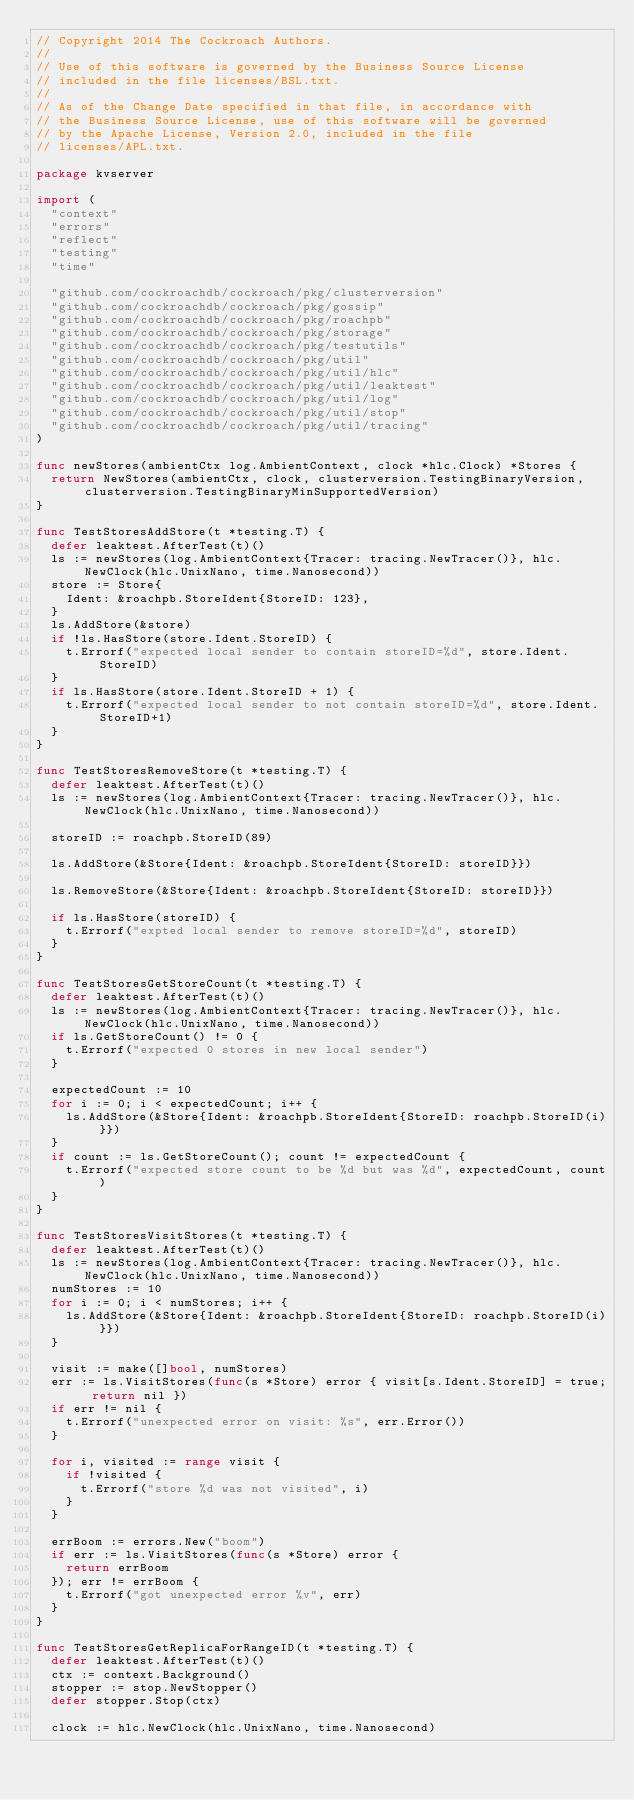Convert code to text. <code><loc_0><loc_0><loc_500><loc_500><_Go_>// Copyright 2014 The Cockroach Authors.
//
// Use of this software is governed by the Business Source License
// included in the file licenses/BSL.txt.
//
// As of the Change Date specified in that file, in accordance with
// the Business Source License, use of this software will be governed
// by the Apache License, Version 2.0, included in the file
// licenses/APL.txt.

package kvserver

import (
	"context"
	"errors"
	"reflect"
	"testing"
	"time"

	"github.com/cockroachdb/cockroach/pkg/clusterversion"
	"github.com/cockroachdb/cockroach/pkg/gossip"
	"github.com/cockroachdb/cockroach/pkg/roachpb"
	"github.com/cockroachdb/cockroach/pkg/storage"
	"github.com/cockroachdb/cockroach/pkg/testutils"
	"github.com/cockroachdb/cockroach/pkg/util"
	"github.com/cockroachdb/cockroach/pkg/util/hlc"
	"github.com/cockroachdb/cockroach/pkg/util/leaktest"
	"github.com/cockroachdb/cockroach/pkg/util/log"
	"github.com/cockroachdb/cockroach/pkg/util/stop"
	"github.com/cockroachdb/cockroach/pkg/util/tracing"
)

func newStores(ambientCtx log.AmbientContext, clock *hlc.Clock) *Stores {
	return NewStores(ambientCtx, clock, clusterversion.TestingBinaryVersion, clusterversion.TestingBinaryMinSupportedVersion)
}

func TestStoresAddStore(t *testing.T) {
	defer leaktest.AfterTest(t)()
	ls := newStores(log.AmbientContext{Tracer: tracing.NewTracer()}, hlc.NewClock(hlc.UnixNano, time.Nanosecond))
	store := Store{
		Ident: &roachpb.StoreIdent{StoreID: 123},
	}
	ls.AddStore(&store)
	if !ls.HasStore(store.Ident.StoreID) {
		t.Errorf("expected local sender to contain storeID=%d", store.Ident.StoreID)
	}
	if ls.HasStore(store.Ident.StoreID + 1) {
		t.Errorf("expected local sender to not contain storeID=%d", store.Ident.StoreID+1)
	}
}

func TestStoresRemoveStore(t *testing.T) {
	defer leaktest.AfterTest(t)()
	ls := newStores(log.AmbientContext{Tracer: tracing.NewTracer()}, hlc.NewClock(hlc.UnixNano, time.Nanosecond))

	storeID := roachpb.StoreID(89)

	ls.AddStore(&Store{Ident: &roachpb.StoreIdent{StoreID: storeID}})

	ls.RemoveStore(&Store{Ident: &roachpb.StoreIdent{StoreID: storeID}})

	if ls.HasStore(storeID) {
		t.Errorf("expted local sender to remove storeID=%d", storeID)
	}
}

func TestStoresGetStoreCount(t *testing.T) {
	defer leaktest.AfterTest(t)()
	ls := newStores(log.AmbientContext{Tracer: tracing.NewTracer()}, hlc.NewClock(hlc.UnixNano, time.Nanosecond))
	if ls.GetStoreCount() != 0 {
		t.Errorf("expected 0 stores in new local sender")
	}

	expectedCount := 10
	for i := 0; i < expectedCount; i++ {
		ls.AddStore(&Store{Ident: &roachpb.StoreIdent{StoreID: roachpb.StoreID(i)}})
	}
	if count := ls.GetStoreCount(); count != expectedCount {
		t.Errorf("expected store count to be %d but was %d", expectedCount, count)
	}
}

func TestStoresVisitStores(t *testing.T) {
	defer leaktest.AfterTest(t)()
	ls := newStores(log.AmbientContext{Tracer: tracing.NewTracer()}, hlc.NewClock(hlc.UnixNano, time.Nanosecond))
	numStores := 10
	for i := 0; i < numStores; i++ {
		ls.AddStore(&Store{Ident: &roachpb.StoreIdent{StoreID: roachpb.StoreID(i)}})
	}

	visit := make([]bool, numStores)
	err := ls.VisitStores(func(s *Store) error { visit[s.Ident.StoreID] = true; return nil })
	if err != nil {
		t.Errorf("unexpected error on visit: %s", err.Error())
	}

	for i, visited := range visit {
		if !visited {
			t.Errorf("store %d was not visited", i)
		}
	}

	errBoom := errors.New("boom")
	if err := ls.VisitStores(func(s *Store) error {
		return errBoom
	}); err != errBoom {
		t.Errorf("got unexpected error %v", err)
	}
}

func TestStoresGetReplicaForRangeID(t *testing.T) {
	defer leaktest.AfterTest(t)()
	ctx := context.Background()
	stopper := stop.NewStopper()
	defer stopper.Stop(ctx)

	clock := hlc.NewClock(hlc.UnixNano, time.Nanosecond)
</code> 